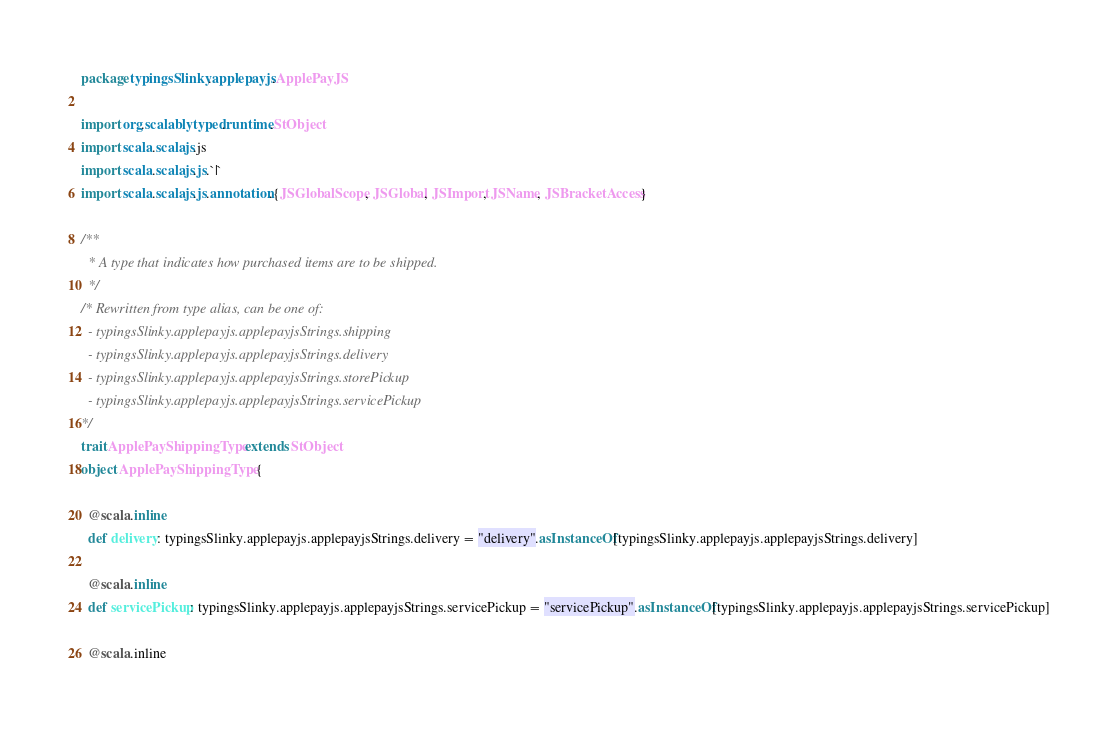<code> <loc_0><loc_0><loc_500><loc_500><_Scala_>package typingsSlinky.applepayjs.ApplePayJS

import org.scalablytyped.runtime.StObject
import scala.scalajs.js
import scala.scalajs.js.`|`
import scala.scalajs.js.annotation.{JSGlobalScope, JSGlobal, JSImport, JSName, JSBracketAccess}

/**
  * A type that indicates how purchased items are to be shipped.
  */
/* Rewritten from type alias, can be one of: 
  - typingsSlinky.applepayjs.applepayjsStrings.shipping
  - typingsSlinky.applepayjs.applepayjsStrings.delivery
  - typingsSlinky.applepayjs.applepayjsStrings.storePickup
  - typingsSlinky.applepayjs.applepayjsStrings.servicePickup
*/
trait ApplePayShippingType extends StObject
object ApplePayShippingType {
  
  @scala.inline
  def delivery: typingsSlinky.applepayjs.applepayjsStrings.delivery = "delivery".asInstanceOf[typingsSlinky.applepayjs.applepayjsStrings.delivery]
  
  @scala.inline
  def servicePickup: typingsSlinky.applepayjs.applepayjsStrings.servicePickup = "servicePickup".asInstanceOf[typingsSlinky.applepayjs.applepayjsStrings.servicePickup]
  
  @scala.inline</code> 